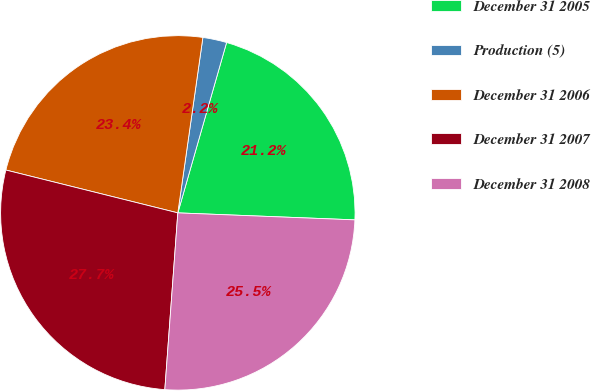Convert chart. <chart><loc_0><loc_0><loc_500><loc_500><pie_chart><fcel>December 31 2005<fcel>Production (5)<fcel>December 31 2006<fcel>December 31 2007<fcel>December 31 2008<nl><fcel>21.19%<fcel>2.18%<fcel>23.37%<fcel>27.72%<fcel>25.54%<nl></chart> 